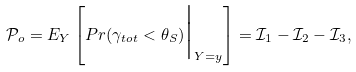<formula> <loc_0><loc_0><loc_500><loc_500>\mathcal { P } _ { o } = E _ { Y } \left [ P r ( \gamma _ { t o t } < \theta _ { S } ) \Big | _ { Y = y } \right ] = \mathcal { I } _ { 1 } - \mathcal { I } _ { 2 } - \mathcal { I } _ { 3 } ,</formula> 